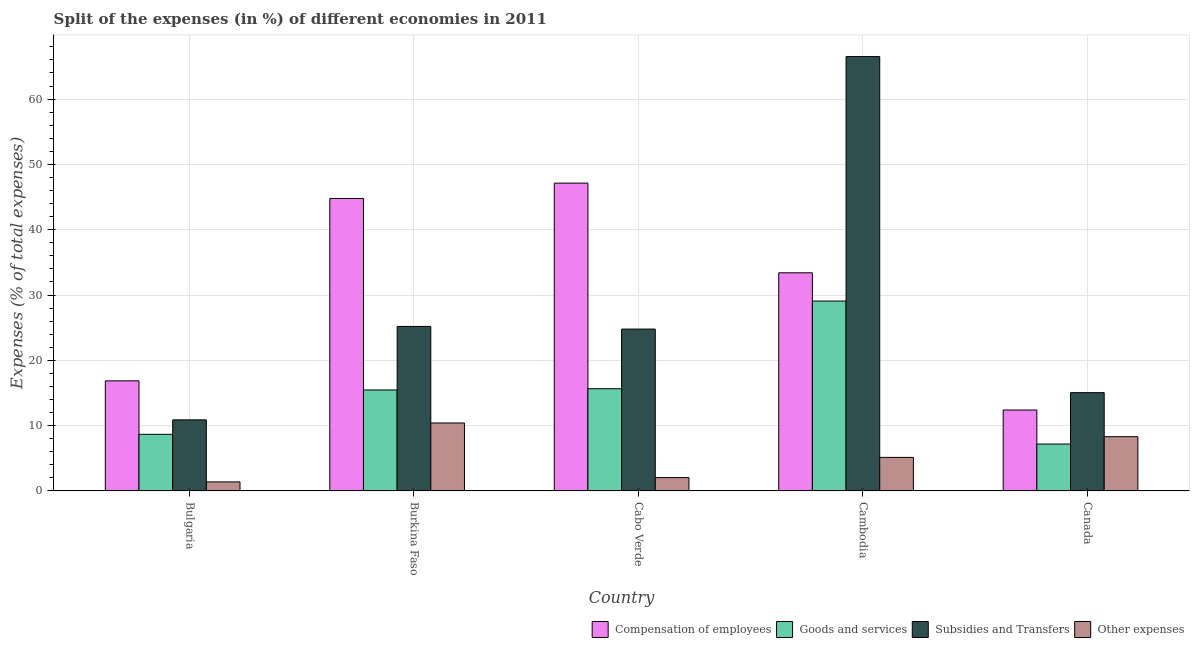How many different coloured bars are there?
Offer a terse response. 4. Are the number of bars per tick equal to the number of legend labels?
Provide a succinct answer. Yes. What is the label of the 2nd group of bars from the left?
Provide a succinct answer. Burkina Faso. In how many cases, is the number of bars for a given country not equal to the number of legend labels?
Your answer should be compact. 0. What is the percentage of amount spent on other expenses in Burkina Faso?
Offer a terse response. 10.41. Across all countries, what is the maximum percentage of amount spent on goods and services?
Provide a succinct answer. 29.08. Across all countries, what is the minimum percentage of amount spent on goods and services?
Offer a terse response. 7.18. In which country was the percentage of amount spent on goods and services maximum?
Provide a succinct answer. Cambodia. What is the total percentage of amount spent on subsidies in the graph?
Your answer should be compact. 142.43. What is the difference between the percentage of amount spent on goods and services in Burkina Faso and that in Canada?
Offer a terse response. 8.28. What is the difference between the percentage of amount spent on goods and services in Cambodia and the percentage of amount spent on subsidies in Canada?
Your answer should be compact. 14.03. What is the average percentage of amount spent on compensation of employees per country?
Offer a terse response. 30.92. What is the difference between the percentage of amount spent on compensation of employees and percentage of amount spent on other expenses in Cabo Verde?
Ensure brevity in your answer.  45.09. What is the ratio of the percentage of amount spent on other expenses in Bulgaria to that in Cabo Verde?
Give a very brief answer. 0.68. Is the percentage of amount spent on other expenses in Cambodia less than that in Canada?
Offer a very short reply. Yes. Is the difference between the percentage of amount spent on subsidies in Bulgaria and Cabo Verde greater than the difference between the percentage of amount spent on goods and services in Bulgaria and Cabo Verde?
Offer a very short reply. No. What is the difference between the highest and the second highest percentage of amount spent on compensation of employees?
Your answer should be very brief. 2.35. What is the difference between the highest and the lowest percentage of amount spent on subsidies?
Make the answer very short. 55.63. In how many countries, is the percentage of amount spent on other expenses greater than the average percentage of amount spent on other expenses taken over all countries?
Make the answer very short. 2. Is the sum of the percentage of amount spent on goods and services in Burkina Faso and Cambodia greater than the maximum percentage of amount spent on other expenses across all countries?
Provide a short and direct response. Yes. What does the 1st bar from the left in Bulgaria represents?
Your answer should be very brief. Compensation of employees. What does the 2nd bar from the right in Canada represents?
Make the answer very short. Subsidies and Transfers. Is it the case that in every country, the sum of the percentage of amount spent on compensation of employees and percentage of amount spent on goods and services is greater than the percentage of amount spent on subsidies?
Give a very brief answer. No. How many countries are there in the graph?
Make the answer very short. 5. What is the difference between two consecutive major ticks on the Y-axis?
Provide a short and direct response. 10. Where does the legend appear in the graph?
Your answer should be compact. Bottom right. What is the title of the graph?
Provide a succinct answer. Split of the expenses (in %) of different economies in 2011. Does "Other Minerals" appear as one of the legend labels in the graph?
Offer a terse response. No. What is the label or title of the X-axis?
Ensure brevity in your answer.  Country. What is the label or title of the Y-axis?
Keep it short and to the point. Expenses (% of total expenses). What is the Expenses (% of total expenses) of Compensation of employees in Bulgaria?
Provide a short and direct response. 16.86. What is the Expenses (% of total expenses) in Goods and services in Bulgaria?
Make the answer very short. 8.67. What is the Expenses (% of total expenses) in Subsidies and Transfers in Bulgaria?
Your response must be concise. 10.89. What is the Expenses (% of total expenses) of Other expenses in Bulgaria?
Make the answer very short. 1.38. What is the Expenses (% of total expenses) of Compensation of employees in Burkina Faso?
Your answer should be very brief. 44.79. What is the Expenses (% of total expenses) in Goods and services in Burkina Faso?
Provide a succinct answer. 15.46. What is the Expenses (% of total expenses) in Subsidies and Transfers in Burkina Faso?
Your answer should be very brief. 25.19. What is the Expenses (% of total expenses) of Other expenses in Burkina Faso?
Give a very brief answer. 10.41. What is the Expenses (% of total expenses) in Compensation of employees in Cabo Verde?
Your answer should be very brief. 47.14. What is the Expenses (% of total expenses) in Goods and services in Cabo Verde?
Ensure brevity in your answer.  15.66. What is the Expenses (% of total expenses) of Subsidies and Transfers in Cabo Verde?
Your answer should be very brief. 24.79. What is the Expenses (% of total expenses) of Other expenses in Cabo Verde?
Keep it short and to the point. 2.04. What is the Expenses (% of total expenses) of Compensation of employees in Cambodia?
Offer a very short reply. 33.4. What is the Expenses (% of total expenses) in Goods and services in Cambodia?
Make the answer very short. 29.08. What is the Expenses (% of total expenses) in Subsidies and Transfers in Cambodia?
Make the answer very short. 66.51. What is the Expenses (% of total expenses) in Other expenses in Cambodia?
Provide a succinct answer. 5.14. What is the Expenses (% of total expenses) in Compensation of employees in Canada?
Ensure brevity in your answer.  12.39. What is the Expenses (% of total expenses) of Goods and services in Canada?
Provide a succinct answer. 7.18. What is the Expenses (% of total expenses) in Subsidies and Transfers in Canada?
Give a very brief answer. 15.05. What is the Expenses (% of total expenses) of Other expenses in Canada?
Make the answer very short. 8.3. Across all countries, what is the maximum Expenses (% of total expenses) of Compensation of employees?
Provide a succinct answer. 47.14. Across all countries, what is the maximum Expenses (% of total expenses) of Goods and services?
Make the answer very short. 29.08. Across all countries, what is the maximum Expenses (% of total expenses) of Subsidies and Transfers?
Offer a terse response. 66.51. Across all countries, what is the maximum Expenses (% of total expenses) in Other expenses?
Keep it short and to the point. 10.41. Across all countries, what is the minimum Expenses (% of total expenses) in Compensation of employees?
Offer a very short reply. 12.39. Across all countries, what is the minimum Expenses (% of total expenses) of Goods and services?
Give a very brief answer. 7.18. Across all countries, what is the minimum Expenses (% of total expenses) of Subsidies and Transfers?
Provide a succinct answer. 10.89. Across all countries, what is the minimum Expenses (% of total expenses) in Other expenses?
Offer a very short reply. 1.38. What is the total Expenses (% of total expenses) in Compensation of employees in the graph?
Offer a terse response. 154.58. What is the total Expenses (% of total expenses) of Goods and services in the graph?
Your answer should be compact. 76.05. What is the total Expenses (% of total expenses) in Subsidies and Transfers in the graph?
Your response must be concise. 142.43. What is the total Expenses (% of total expenses) of Other expenses in the graph?
Offer a terse response. 27.28. What is the difference between the Expenses (% of total expenses) in Compensation of employees in Bulgaria and that in Burkina Faso?
Give a very brief answer. -27.93. What is the difference between the Expenses (% of total expenses) in Goods and services in Bulgaria and that in Burkina Faso?
Make the answer very short. -6.79. What is the difference between the Expenses (% of total expenses) in Subsidies and Transfers in Bulgaria and that in Burkina Faso?
Provide a succinct answer. -14.31. What is the difference between the Expenses (% of total expenses) in Other expenses in Bulgaria and that in Burkina Faso?
Offer a very short reply. -9.02. What is the difference between the Expenses (% of total expenses) of Compensation of employees in Bulgaria and that in Cabo Verde?
Offer a terse response. -30.28. What is the difference between the Expenses (% of total expenses) of Goods and services in Bulgaria and that in Cabo Verde?
Make the answer very short. -6.99. What is the difference between the Expenses (% of total expenses) in Subsidies and Transfers in Bulgaria and that in Cabo Verde?
Offer a terse response. -13.9. What is the difference between the Expenses (% of total expenses) in Other expenses in Bulgaria and that in Cabo Verde?
Provide a succinct answer. -0.66. What is the difference between the Expenses (% of total expenses) in Compensation of employees in Bulgaria and that in Cambodia?
Provide a short and direct response. -16.55. What is the difference between the Expenses (% of total expenses) in Goods and services in Bulgaria and that in Cambodia?
Offer a very short reply. -20.41. What is the difference between the Expenses (% of total expenses) of Subsidies and Transfers in Bulgaria and that in Cambodia?
Provide a succinct answer. -55.63. What is the difference between the Expenses (% of total expenses) of Other expenses in Bulgaria and that in Cambodia?
Keep it short and to the point. -3.75. What is the difference between the Expenses (% of total expenses) of Compensation of employees in Bulgaria and that in Canada?
Offer a terse response. 4.46. What is the difference between the Expenses (% of total expenses) in Goods and services in Bulgaria and that in Canada?
Give a very brief answer. 1.49. What is the difference between the Expenses (% of total expenses) in Subsidies and Transfers in Bulgaria and that in Canada?
Provide a short and direct response. -4.16. What is the difference between the Expenses (% of total expenses) of Other expenses in Bulgaria and that in Canada?
Provide a short and direct response. -6.92. What is the difference between the Expenses (% of total expenses) of Compensation of employees in Burkina Faso and that in Cabo Verde?
Offer a very short reply. -2.35. What is the difference between the Expenses (% of total expenses) of Goods and services in Burkina Faso and that in Cabo Verde?
Provide a short and direct response. -0.19. What is the difference between the Expenses (% of total expenses) of Subsidies and Transfers in Burkina Faso and that in Cabo Verde?
Make the answer very short. 0.41. What is the difference between the Expenses (% of total expenses) of Other expenses in Burkina Faso and that in Cabo Verde?
Offer a very short reply. 8.36. What is the difference between the Expenses (% of total expenses) of Compensation of employees in Burkina Faso and that in Cambodia?
Make the answer very short. 11.38. What is the difference between the Expenses (% of total expenses) of Goods and services in Burkina Faso and that in Cambodia?
Give a very brief answer. -13.61. What is the difference between the Expenses (% of total expenses) of Subsidies and Transfers in Burkina Faso and that in Cambodia?
Offer a terse response. -41.32. What is the difference between the Expenses (% of total expenses) of Other expenses in Burkina Faso and that in Cambodia?
Keep it short and to the point. 5.27. What is the difference between the Expenses (% of total expenses) of Compensation of employees in Burkina Faso and that in Canada?
Provide a short and direct response. 32.39. What is the difference between the Expenses (% of total expenses) in Goods and services in Burkina Faso and that in Canada?
Provide a short and direct response. 8.28. What is the difference between the Expenses (% of total expenses) of Subsidies and Transfers in Burkina Faso and that in Canada?
Your answer should be very brief. 10.14. What is the difference between the Expenses (% of total expenses) in Other expenses in Burkina Faso and that in Canada?
Your answer should be very brief. 2.1. What is the difference between the Expenses (% of total expenses) of Compensation of employees in Cabo Verde and that in Cambodia?
Keep it short and to the point. 13.73. What is the difference between the Expenses (% of total expenses) of Goods and services in Cabo Verde and that in Cambodia?
Offer a very short reply. -13.42. What is the difference between the Expenses (% of total expenses) in Subsidies and Transfers in Cabo Verde and that in Cambodia?
Offer a terse response. -41.73. What is the difference between the Expenses (% of total expenses) of Other expenses in Cabo Verde and that in Cambodia?
Your response must be concise. -3.09. What is the difference between the Expenses (% of total expenses) in Compensation of employees in Cabo Verde and that in Canada?
Your response must be concise. 34.74. What is the difference between the Expenses (% of total expenses) of Goods and services in Cabo Verde and that in Canada?
Provide a short and direct response. 8.47. What is the difference between the Expenses (% of total expenses) in Subsidies and Transfers in Cabo Verde and that in Canada?
Your response must be concise. 9.74. What is the difference between the Expenses (% of total expenses) in Other expenses in Cabo Verde and that in Canada?
Your answer should be compact. -6.26. What is the difference between the Expenses (% of total expenses) in Compensation of employees in Cambodia and that in Canada?
Provide a short and direct response. 21.01. What is the difference between the Expenses (% of total expenses) of Goods and services in Cambodia and that in Canada?
Provide a succinct answer. 21.89. What is the difference between the Expenses (% of total expenses) of Subsidies and Transfers in Cambodia and that in Canada?
Keep it short and to the point. 51.46. What is the difference between the Expenses (% of total expenses) of Other expenses in Cambodia and that in Canada?
Keep it short and to the point. -3.17. What is the difference between the Expenses (% of total expenses) of Compensation of employees in Bulgaria and the Expenses (% of total expenses) of Goods and services in Burkina Faso?
Offer a terse response. 1.39. What is the difference between the Expenses (% of total expenses) in Compensation of employees in Bulgaria and the Expenses (% of total expenses) in Subsidies and Transfers in Burkina Faso?
Your answer should be very brief. -8.34. What is the difference between the Expenses (% of total expenses) in Compensation of employees in Bulgaria and the Expenses (% of total expenses) in Other expenses in Burkina Faso?
Ensure brevity in your answer.  6.45. What is the difference between the Expenses (% of total expenses) in Goods and services in Bulgaria and the Expenses (% of total expenses) in Subsidies and Transfers in Burkina Faso?
Your answer should be very brief. -16.52. What is the difference between the Expenses (% of total expenses) of Goods and services in Bulgaria and the Expenses (% of total expenses) of Other expenses in Burkina Faso?
Keep it short and to the point. -1.74. What is the difference between the Expenses (% of total expenses) of Subsidies and Transfers in Bulgaria and the Expenses (% of total expenses) of Other expenses in Burkina Faso?
Provide a short and direct response. 0.48. What is the difference between the Expenses (% of total expenses) of Compensation of employees in Bulgaria and the Expenses (% of total expenses) of Goods and services in Cabo Verde?
Make the answer very short. 1.2. What is the difference between the Expenses (% of total expenses) in Compensation of employees in Bulgaria and the Expenses (% of total expenses) in Subsidies and Transfers in Cabo Verde?
Provide a succinct answer. -7.93. What is the difference between the Expenses (% of total expenses) in Compensation of employees in Bulgaria and the Expenses (% of total expenses) in Other expenses in Cabo Verde?
Provide a succinct answer. 14.81. What is the difference between the Expenses (% of total expenses) in Goods and services in Bulgaria and the Expenses (% of total expenses) in Subsidies and Transfers in Cabo Verde?
Offer a very short reply. -16.12. What is the difference between the Expenses (% of total expenses) in Goods and services in Bulgaria and the Expenses (% of total expenses) in Other expenses in Cabo Verde?
Keep it short and to the point. 6.63. What is the difference between the Expenses (% of total expenses) in Subsidies and Transfers in Bulgaria and the Expenses (% of total expenses) in Other expenses in Cabo Verde?
Your response must be concise. 8.84. What is the difference between the Expenses (% of total expenses) in Compensation of employees in Bulgaria and the Expenses (% of total expenses) in Goods and services in Cambodia?
Offer a very short reply. -12.22. What is the difference between the Expenses (% of total expenses) in Compensation of employees in Bulgaria and the Expenses (% of total expenses) in Subsidies and Transfers in Cambodia?
Provide a succinct answer. -49.66. What is the difference between the Expenses (% of total expenses) in Compensation of employees in Bulgaria and the Expenses (% of total expenses) in Other expenses in Cambodia?
Give a very brief answer. 11.72. What is the difference between the Expenses (% of total expenses) in Goods and services in Bulgaria and the Expenses (% of total expenses) in Subsidies and Transfers in Cambodia?
Offer a terse response. -57.84. What is the difference between the Expenses (% of total expenses) in Goods and services in Bulgaria and the Expenses (% of total expenses) in Other expenses in Cambodia?
Make the answer very short. 3.53. What is the difference between the Expenses (% of total expenses) in Subsidies and Transfers in Bulgaria and the Expenses (% of total expenses) in Other expenses in Cambodia?
Keep it short and to the point. 5.75. What is the difference between the Expenses (% of total expenses) in Compensation of employees in Bulgaria and the Expenses (% of total expenses) in Goods and services in Canada?
Offer a terse response. 9.67. What is the difference between the Expenses (% of total expenses) of Compensation of employees in Bulgaria and the Expenses (% of total expenses) of Subsidies and Transfers in Canada?
Your answer should be very brief. 1.81. What is the difference between the Expenses (% of total expenses) in Compensation of employees in Bulgaria and the Expenses (% of total expenses) in Other expenses in Canada?
Your response must be concise. 8.55. What is the difference between the Expenses (% of total expenses) in Goods and services in Bulgaria and the Expenses (% of total expenses) in Subsidies and Transfers in Canada?
Your response must be concise. -6.38. What is the difference between the Expenses (% of total expenses) in Goods and services in Bulgaria and the Expenses (% of total expenses) in Other expenses in Canada?
Keep it short and to the point. 0.37. What is the difference between the Expenses (% of total expenses) in Subsidies and Transfers in Bulgaria and the Expenses (% of total expenses) in Other expenses in Canada?
Offer a terse response. 2.58. What is the difference between the Expenses (% of total expenses) in Compensation of employees in Burkina Faso and the Expenses (% of total expenses) in Goods and services in Cabo Verde?
Provide a succinct answer. 29.13. What is the difference between the Expenses (% of total expenses) in Compensation of employees in Burkina Faso and the Expenses (% of total expenses) in Subsidies and Transfers in Cabo Verde?
Make the answer very short. 20. What is the difference between the Expenses (% of total expenses) of Compensation of employees in Burkina Faso and the Expenses (% of total expenses) of Other expenses in Cabo Verde?
Offer a terse response. 42.74. What is the difference between the Expenses (% of total expenses) in Goods and services in Burkina Faso and the Expenses (% of total expenses) in Subsidies and Transfers in Cabo Verde?
Provide a succinct answer. -9.32. What is the difference between the Expenses (% of total expenses) of Goods and services in Burkina Faso and the Expenses (% of total expenses) of Other expenses in Cabo Verde?
Offer a terse response. 13.42. What is the difference between the Expenses (% of total expenses) in Subsidies and Transfers in Burkina Faso and the Expenses (% of total expenses) in Other expenses in Cabo Verde?
Ensure brevity in your answer.  23.15. What is the difference between the Expenses (% of total expenses) in Compensation of employees in Burkina Faso and the Expenses (% of total expenses) in Goods and services in Cambodia?
Provide a short and direct response. 15.71. What is the difference between the Expenses (% of total expenses) in Compensation of employees in Burkina Faso and the Expenses (% of total expenses) in Subsidies and Transfers in Cambodia?
Your answer should be very brief. -21.72. What is the difference between the Expenses (% of total expenses) of Compensation of employees in Burkina Faso and the Expenses (% of total expenses) of Other expenses in Cambodia?
Your answer should be very brief. 39.65. What is the difference between the Expenses (% of total expenses) of Goods and services in Burkina Faso and the Expenses (% of total expenses) of Subsidies and Transfers in Cambodia?
Make the answer very short. -51.05. What is the difference between the Expenses (% of total expenses) of Goods and services in Burkina Faso and the Expenses (% of total expenses) of Other expenses in Cambodia?
Make the answer very short. 10.33. What is the difference between the Expenses (% of total expenses) of Subsidies and Transfers in Burkina Faso and the Expenses (% of total expenses) of Other expenses in Cambodia?
Provide a short and direct response. 20.06. What is the difference between the Expenses (% of total expenses) in Compensation of employees in Burkina Faso and the Expenses (% of total expenses) in Goods and services in Canada?
Give a very brief answer. 37.61. What is the difference between the Expenses (% of total expenses) in Compensation of employees in Burkina Faso and the Expenses (% of total expenses) in Subsidies and Transfers in Canada?
Ensure brevity in your answer.  29.74. What is the difference between the Expenses (% of total expenses) in Compensation of employees in Burkina Faso and the Expenses (% of total expenses) in Other expenses in Canada?
Make the answer very short. 36.48. What is the difference between the Expenses (% of total expenses) in Goods and services in Burkina Faso and the Expenses (% of total expenses) in Subsidies and Transfers in Canada?
Provide a short and direct response. 0.41. What is the difference between the Expenses (% of total expenses) of Goods and services in Burkina Faso and the Expenses (% of total expenses) of Other expenses in Canada?
Your response must be concise. 7.16. What is the difference between the Expenses (% of total expenses) in Subsidies and Transfers in Burkina Faso and the Expenses (% of total expenses) in Other expenses in Canada?
Your answer should be compact. 16.89. What is the difference between the Expenses (% of total expenses) in Compensation of employees in Cabo Verde and the Expenses (% of total expenses) in Goods and services in Cambodia?
Keep it short and to the point. 18.06. What is the difference between the Expenses (% of total expenses) of Compensation of employees in Cabo Verde and the Expenses (% of total expenses) of Subsidies and Transfers in Cambodia?
Ensure brevity in your answer.  -19.38. What is the difference between the Expenses (% of total expenses) in Compensation of employees in Cabo Verde and the Expenses (% of total expenses) in Other expenses in Cambodia?
Give a very brief answer. 42. What is the difference between the Expenses (% of total expenses) in Goods and services in Cabo Verde and the Expenses (% of total expenses) in Subsidies and Transfers in Cambodia?
Keep it short and to the point. -50.86. What is the difference between the Expenses (% of total expenses) in Goods and services in Cabo Verde and the Expenses (% of total expenses) in Other expenses in Cambodia?
Offer a terse response. 10.52. What is the difference between the Expenses (% of total expenses) in Subsidies and Transfers in Cabo Verde and the Expenses (% of total expenses) in Other expenses in Cambodia?
Offer a very short reply. 19.65. What is the difference between the Expenses (% of total expenses) of Compensation of employees in Cabo Verde and the Expenses (% of total expenses) of Goods and services in Canada?
Your response must be concise. 39.96. What is the difference between the Expenses (% of total expenses) of Compensation of employees in Cabo Verde and the Expenses (% of total expenses) of Subsidies and Transfers in Canada?
Give a very brief answer. 32.09. What is the difference between the Expenses (% of total expenses) in Compensation of employees in Cabo Verde and the Expenses (% of total expenses) in Other expenses in Canada?
Keep it short and to the point. 38.83. What is the difference between the Expenses (% of total expenses) of Goods and services in Cabo Verde and the Expenses (% of total expenses) of Subsidies and Transfers in Canada?
Give a very brief answer. 0.61. What is the difference between the Expenses (% of total expenses) of Goods and services in Cabo Verde and the Expenses (% of total expenses) of Other expenses in Canada?
Offer a very short reply. 7.35. What is the difference between the Expenses (% of total expenses) of Subsidies and Transfers in Cabo Verde and the Expenses (% of total expenses) of Other expenses in Canada?
Make the answer very short. 16.48. What is the difference between the Expenses (% of total expenses) of Compensation of employees in Cambodia and the Expenses (% of total expenses) of Goods and services in Canada?
Offer a terse response. 26.22. What is the difference between the Expenses (% of total expenses) of Compensation of employees in Cambodia and the Expenses (% of total expenses) of Subsidies and Transfers in Canada?
Provide a succinct answer. 18.35. What is the difference between the Expenses (% of total expenses) of Compensation of employees in Cambodia and the Expenses (% of total expenses) of Other expenses in Canada?
Offer a very short reply. 25.1. What is the difference between the Expenses (% of total expenses) in Goods and services in Cambodia and the Expenses (% of total expenses) in Subsidies and Transfers in Canada?
Keep it short and to the point. 14.03. What is the difference between the Expenses (% of total expenses) in Goods and services in Cambodia and the Expenses (% of total expenses) in Other expenses in Canada?
Offer a terse response. 20.77. What is the difference between the Expenses (% of total expenses) of Subsidies and Transfers in Cambodia and the Expenses (% of total expenses) of Other expenses in Canada?
Your answer should be very brief. 58.21. What is the average Expenses (% of total expenses) of Compensation of employees per country?
Provide a short and direct response. 30.92. What is the average Expenses (% of total expenses) of Goods and services per country?
Make the answer very short. 15.21. What is the average Expenses (% of total expenses) in Subsidies and Transfers per country?
Offer a terse response. 28.49. What is the average Expenses (% of total expenses) of Other expenses per country?
Give a very brief answer. 5.46. What is the difference between the Expenses (% of total expenses) of Compensation of employees and Expenses (% of total expenses) of Goods and services in Bulgaria?
Provide a short and direct response. 8.19. What is the difference between the Expenses (% of total expenses) in Compensation of employees and Expenses (% of total expenses) in Subsidies and Transfers in Bulgaria?
Keep it short and to the point. 5.97. What is the difference between the Expenses (% of total expenses) of Compensation of employees and Expenses (% of total expenses) of Other expenses in Bulgaria?
Offer a terse response. 15.47. What is the difference between the Expenses (% of total expenses) in Goods and services and Expenses (% of total expenses) in Subsidies and Transfers in Bulgaria?
Your response must be concise. -2.22. What is the difference between the Expenses (% of total expenses) of Goods and services and Expenses (% of total expenses) of Other expenses in Bulgaria?
Offer a very short reply. 7.29. What is the difference between the Expenses (% of total expenses) of Subsidies and Transfers and Expenses (% of total expenses) of Other expenses in Bulgaria?
Offer a very short reply. 9.5. What is the difference between the Expenses (% of total expenses) in Compensation of employees and Expenses (% of total expenses) in Goods and services in Burkina Faso?
Provide a succinct answer. 29.33. What is the difference between the Expenses (% of total expenses) in Compensation of employees and Expenses (% of total expenses) in Subsidies and Transfers in Burkina Faso?
Offer a very short reply. 19.6. What is the difference between the Expenses (% of total expenses) in Compensation of employees and Expenses (% of total expenses) in Other expenses in Burkina Faso?
Provide a short and direct response. 34.38. What is the difference between the Expenses (% of total expenses) of Goods and services and Expenses (% of total expenses) of Subsidies and Transfers in Burkina Faso?
Keep it short and to the point. -9.73. What is the difference between the Expenses (% of total expenses) in Goods and services and Expenses (% of total expenses) in Other expenses in Burkina Faso?
Ensure brevity in your answer.  5.06. What is the difference between the Expenses (% of total expenses) of Subsidies and Transfers and Expenses (% of total expenses) of Other expenses in Burkina Faso?
Make the answer very short. 14.79. What is the difference between the Expenses (% of total expenses) of Compensation of employees and Expenses (% of total expenses) of Goods and services in Cabo Verde?
Ensure brevity in your answer.  31.48. What is the difference between the Expenses (% of total expenses) in Compensation of employees and Expenses (% of total expenses) in Subsidies and Transfers in Cabo Verde?
Provide a short and direct response. 22.35. What is the difference between the Expenses (% of total expenses) in Compensation of employees and Expenses (% of total expenses) in Other expenses in Cabo Verde?
Provide a short and direct response. 45.09. What is the difference between the Expenses (% of total expenses) of Goods and services and Expenses (% of total expenses) of Subsidies and Transfers in Cabo Verde?
Give a very brief answer. -9.13. What is the difference between the Expenses (% of total expenses) in Goods and services and Expenses (% of total expenses) in Other expenses in Cabo Verde?
Your answer should be very brief. 13.61. What is the difference between the Expenses (% of total expenses) of Subsidies and Transfers and Expenses (% of total expenses) of Other expenses in Cabo Verde?
Your response must be concise. 22.74. What is the difference between the Expenses (% of total expenses) of Compensation of employees and Expenses (% of total expenses) of Goods and services in Cambodia?
Make the answer very short. 4.33. What is the difference between the Expenses (% of total expenses) in Compensation of employees and Expenses (% of total expenses) in Subsidies and Transfers in Cambodia?
Offer a very short reply. -33.11. What is the difference between the Expenses (% of total expenses) in Compensation of employees and Expenses (% of total expenses) in Other expenses in Cambodia?
Offer a terse response. 28.27. What is the difference between the Expenses (% of total expenses) of Goods and services and Expenses (% of total expenses) of Subsidies and Transfers in Cambodia?
Your answer should be compact. -37.44. What is the difference between the Expenses (% of total expenses) in Goods and services and Expenses (% of total expenses) in Other expenses in Cambodia?
Provide a short and direct response. 23.94. What is the difference between the Expenses (% of total expenses) in Subsidies and Transfers and Expenses (% of total expenses) in Other expenses in Cambodia?
Your response must be concise. 61.38. What is the difference between the Expenses (% of total expenses) in Compensation of employees and Expenses (% of total expenses) in Goods and services in Canada?
Provide a succinct answer. 5.21. What is the difference between the Expenses (% of total expenses) of Compensation of employees and Expenses (% of total expenses) of Subsidies and Transfers in Canada?
Offer a very short reply. -2.66. What is the difference between the Expenses (% of total expenses) of Compensation of employees and Expenses (% of total expenses) of Other expenses in Canada?
Give a very brief answer. 4.09. What is the difference between the Expenses (% of total expenses) in Goods and services and Expenses (% of total expenses) in Subsidies and Transfers in Canada?
Your response must be concise. -7.87. What is the difference between the Expenses (% of total expenses) in Goods and services and Expenses (% of total expenses) in Other expenses in Canada?
Your answer should be compact. -1.12. What is the difference between the Expenses (% of total expenses) of Subsidies and Transfers and Expenses (% of total expenses) of Other expenses in Canada?
Your answer should be very brief. 6.75. What is the ratio of the Expenses (% of total expenses) of Compensation of employees in Bulgaria to that in Burkina Faso?
Ensure brevity in your answer.  0.38. What is the ratio of the Expenses (% of total expenses) in Goods and services in Bulgaria to that in Burkina Faso?
Your answer should be compact. 0.56. What is the ratio of the Expenses (% of total expenses) of Subsidies and Transfers in Bulgaria to that in Burkina Faso?
Your answer should be very brief. 0.43. What is the ratio of the Expenses (% of total expenses) of Other expenses in Bulgaria to that in Burkina Faso?
Offer a very short reply. 0.13. What is the ratio of the Expenses (% of total expenses) in Compensation of employees in Bulgaria to that in Cabo Verde?
Provide a succinct answer. 0.36. What is the ratio of the Expenses (% of total expenses) of Goods and services in Bulgaria to that in Cabo Verde?
Your answer should be very brief. 0.55. What is the ratio of the Expenses (% of total expenses) in Subsidies and Transfers in Bulgaria to that in Cabo Verde?
Offer a terse response. 0.44. What is the ratio of the Expenses (% of total expenses) in Other expenses in Bulgaria to that in Cabo Verde?
Your response must be concise. 0.68. What is the ratio of the Expenses (% of total expenses) of Compensation of employees in Bulgaria to that in Cambodia?
Provide a short and direct response. 0.5. What is the ratio of the Expenses (% of total expenses) of Goods and services in Bulgaria to that in Cambodia?
Offer a very short reply. 0.3. What is the ratio of the Expenses (% of total expenses) in Subsidies and Transfers in Bulgaria to that in Cambodia?
Provide a succinct answer. 0.16. What is the ratio of the Expenses (% of total expenses) in Other expenses in Bulgaria to that in Cambodia?
Make the answer very short. 0.27. What is the ratio of the Expenses (% of total expenses) of Compensation of employees in Bulgaria to that in Canada?
Make the answer very short. 1.36. What is the ratio of the Expenses (% of total expenses) in Goods and services in Bulgaria to that in Canada?
Your answer should be compact. 1.21. What is the ratio of the Expenses (% of total expenses) in Subsidies and Transfers in Bulgaria to that in Canada?
Your answer should be very brief. 0.72. What is the ratio of the Expenses (% of total expenses) in Other expenses in Bulgaria to that in Canada?
Provide a short and direct response. 0.17. What is the ratio of the Expenses (% of total expenses) of Compensation of employees in Burkina Faso to that in Cabo Verde?
Ensure brevity in your answer.  0.95. What is the ratio of the Expenses (% of total expenses) of Goods and services in Burkina Faso to that in Cabo Verde?
Your response must be concise. 0.99. What is the ratio of the Expenses (% of total expenses) of Subsidies and Transfers in Burkina Faso to that in Cabo Verde?
Your answer should be compact. 1.02. What is the ratio of the Expenses (% of total expenses) in Other expenses in Burkina Faso to that in Cabo Verde?
Make the answer very short. 5.09. What is the ratio of the Expenses (% of total expenses) in Compensation of employees in Burkina Faso to that in Cambodia?
Ensure brevity in your answer.  1.34. What is the ratio of the Expenses (% of total expenses) of Goods and services in Burkina Faso to that in Cambodia?
Your response must be concise. 0.53. What is the ratio of the Expenses (% of total expenses) in Subsidies and Transfers in Burkina Faso to that in Cambodia?
Give a very brief answer. 0.38. What is the ratio of the Expenses (% of total expenses) of Other expenses in Burkina Faso to that in Cambodia?
Make the answer very short. 2.03. What is the ratio of the Expenses (% of total expenses) in Compensation of employees in Burkina Faso to that in Canada?
Offer a terse response. 3.61. What is the ratio of the Expenses (% of total expenses) of Goods and services in Burkina Faso to that in Canada?
Provide a short and direct response. 2.15. What is the ratio of the Expenses (% of total expenses) in Subsidies and Transfers in Burkina Faso to that in Canada?
Provide a succinct answer. 1.67. What is the ratio of the Expenses (% of total expenses) in Other expenses in Burkina Faso to that in Canada?
Offer a terse response. 1.25. What is the ratio of the Expenses (% of total expenses) of Compensation of employees in Cabo Verde to that in Cambodia?
Give a very brief answer. 1.41. What is the ratio of the Expenses (% of total expenses) in Goods and services in Cabo Verde to that in Cambodia?
Keep it short and to the point. 0.54. What is the ratio of the Expenses (% of total expenses) of Subsidies and Transfers in Cabo Verde to that in Cambodia?
Your answer should be very brief. 0.37. What is the ratio of the Expenses (% of total expenses) of Other expenses in Cabo Verde to that in Cambodia?
Your answer should be very brief. 0.4. What is the ratio of the Expenses (% of total expenses) of Compensation of employees in Cabo Verde to that in Canada?
Your answer should be compact. 3.8. What is the ratio of the Expenses (% of total expenses) of Goods and services in Cabo Verde to that in Canada?
Your answer should be compact. 2.18. What is the ratio of the Expenses (% of total expenses) in Subsidies and Transfers in Cabo Verde to that in Canada?
Offer a very short reply. 1.65. What is the ratio of the Expenses (% of total expenses) of Other expenses in Cabo Verde to that in Canada?
Keep it short and to the point. 0.25. What is the ratio of the Expenses (% of total expenses) of Compensation of employees in Cambodia to that in Canada?
Provide a succinct answer. 2.7. What is the ratio of the Expenses (% of total expenses) in Goods and services in Cambodia to that in Canada?
Offer a terse response. 4.05. What is the ratio of the Expenses (% of total expenses) in Subsidies and Transfers in Cambodia to that in Canada?
Provide a short and direct response. 4.42. What is the ratio of the Expenses (% of total expenses) in Other expenses in Cambodia to that in Canada?
Keep it short and to the point. 0.62. What is the difference between the highest and the second highest Expenses (% of total expenses) of Compensation of employees?
Provide a short and direct response. 2.35. What is the difference between the highest and the second highest Expenses (% of total expenses) in Goods and services?
Make the answer very short. 13.42. What is the difference between the highest and the second highest Expenses (% of total expenses) in Subsidies and Transfers?
Your response must be concise. 41.32. What is the difference between the highest and the second highest Expenses (% of total expenses) in Other expenses?
Ensure brevity in your answer.  2.1. What is the difference between the highest and the lowest Expenses (% of total expenses) in Compensation of employees?
Your response must be concise. 34.74. What is the difference between the highest and the lowest Expenses (% of total expenses) in Goods and services?
Provide a short and direct response. 21.89. What is the difference between the highest and the lowest Expenses (% of total expenses) in Subsidies and Transfers?
Offer a terse response. 55.63. What is the difference between the highest and the lowest Expenses (% of total expenses) of Other expenses?
Ensure brevity in your answer.  9.02. 